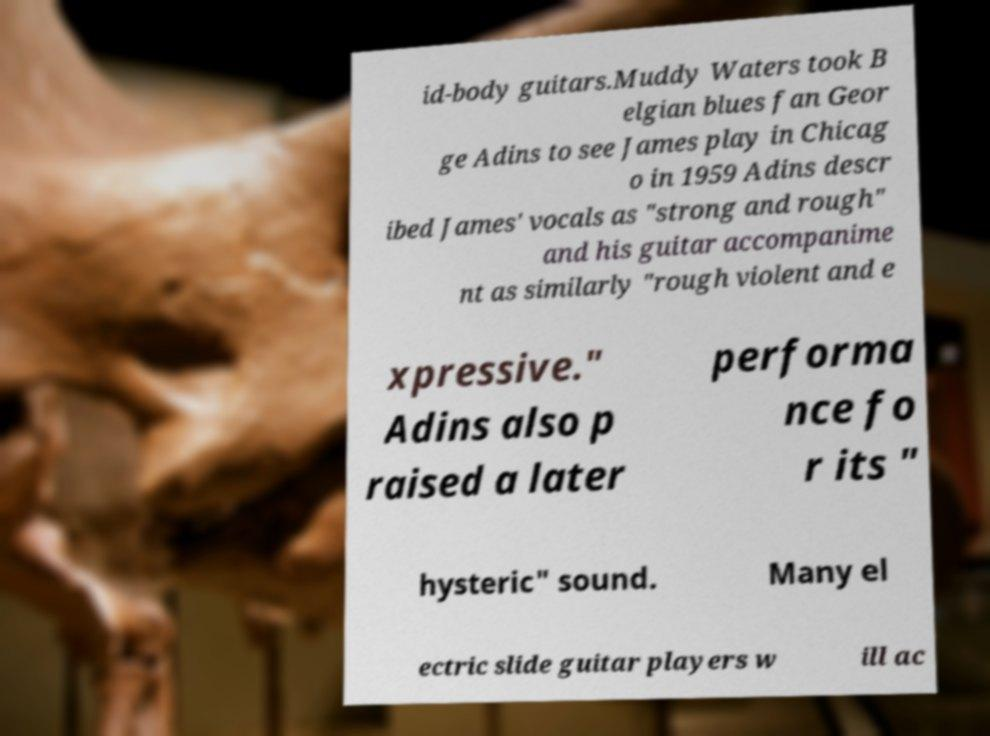I need the written content from this picture converted into text. Can you do that? id-body guitars.Muddy Waters took B elgian blues fan Geor ge Adins to see James play in Chicag o in 1959 Adins descr ibed James' vocals as "strong and rough" and his guitar accompanime nt as similarly "rough violent and e xpressive." Adins also p raised a later performa nce fo r its " hysteric" sound. Many el ectric slide guitar players w ill ac 